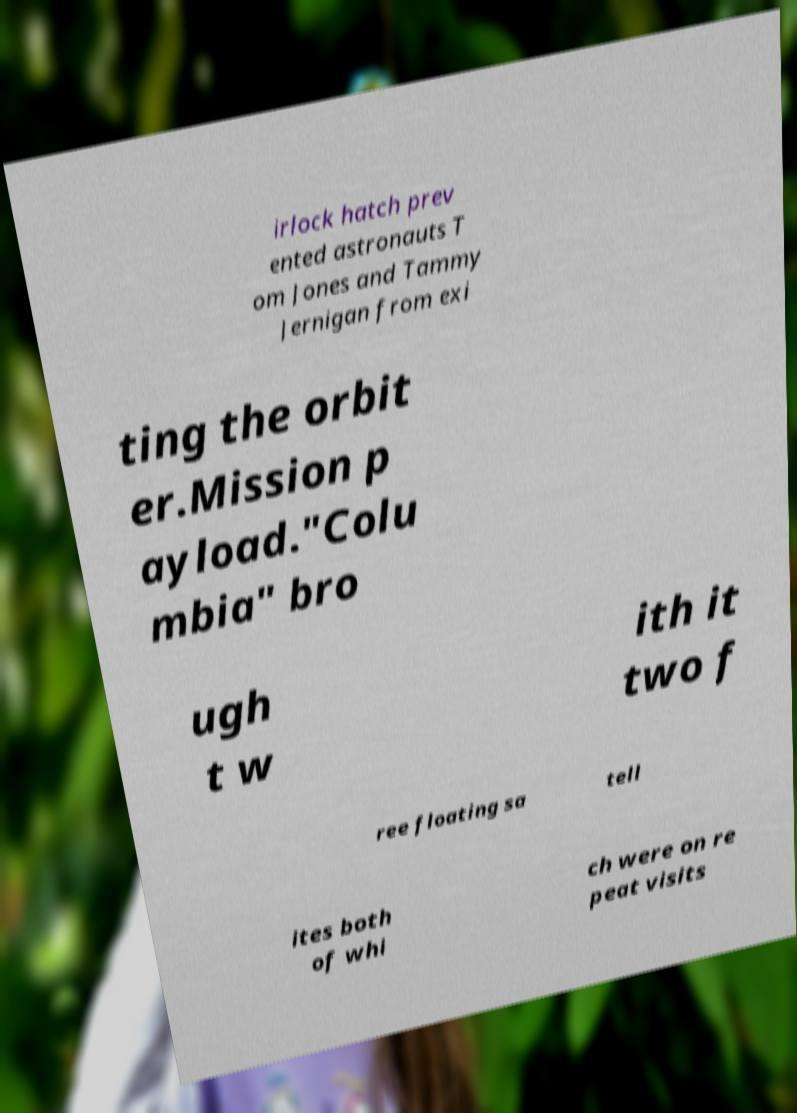There's text embedded in this image that I need extracted. Can you transcribe it verbatim? irlock hatch prev ented astronauts T om Jones and Tammy Jernigan from exi ting the orbit er.Mission p ayload."Colu mbia" bro ugh t w ith it two f ree floating sa tell ites both of whi ch were on re peat visits 